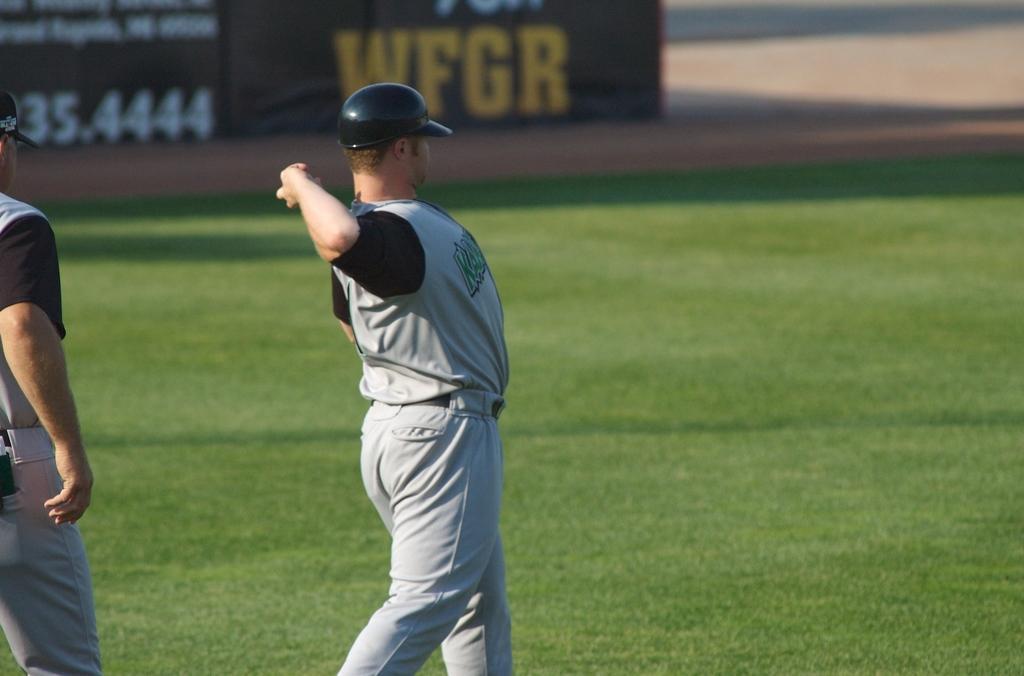In one or two sentences, can you explain what this image depicts? In this image we can see persons standing on the grass. In the background we can see ground. 